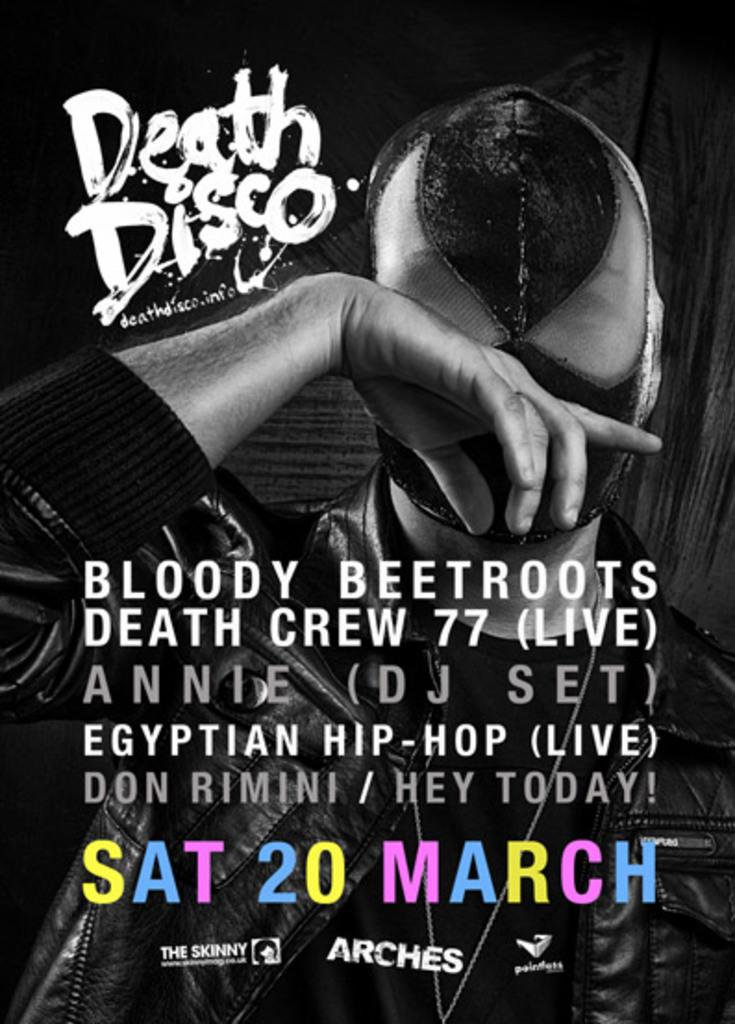Who or what is present in the image? There is a person in the image. What is the person wearing on their face? The person is wearing a mask on their face. Can you describe anything else in the foreground of the image? There is some text in the foreground of the image. How is the mist being distributed in the image? There is no mist present in the image. Is there a baby visible in the image? There is no baby visible in the image. 